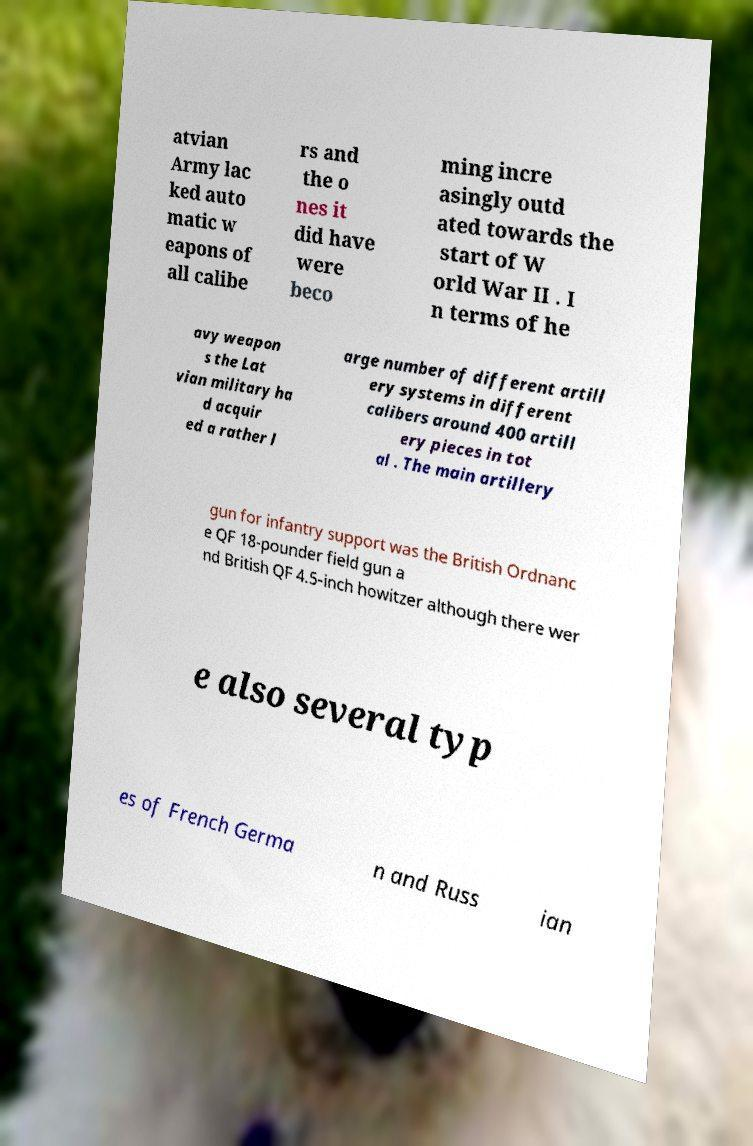For documentation purposes, I need the text within this image transcribed. Could you provide that? atvian Army lac ked auto matic w eapons of all calibe rs and the o nes it did have were beco ming incre asingly outd ated towards the start of W orld War II . I n terms of he avy weapon s the Lat vian military ha d acquir ed a rather l arge number of different artill ery systems in different calibers around 400 artill ery pieces in tot al . The main artillery gun for infantry support was the British Ordnanc e QF 18-pounder field gun a nd British QF 4.5-inch howitzer although there wer e also several typ es of French Germa n and Russ ian 